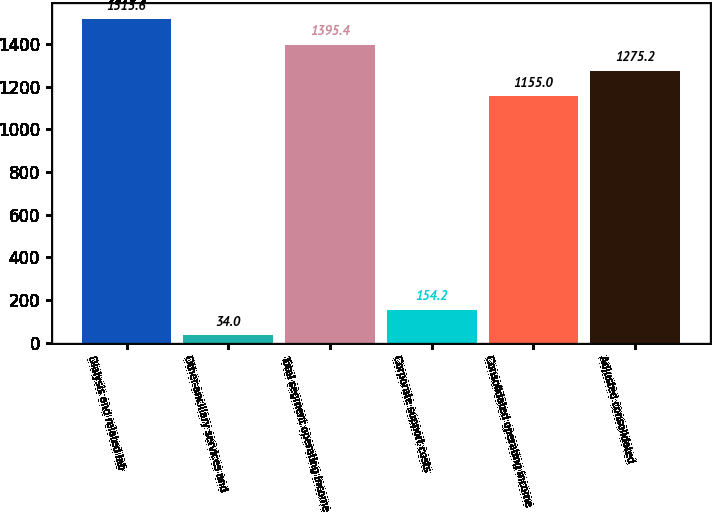<chart> <loc_0><loc_0><loc_500><loc_500><bar_chart><fcel>Dialysis and related lab<fcel>Other-ancillary services and<fcel>Total segment operating income<fcel>Corporate support costs<fcel>Consolidated operating income<fcel>Adjusted consolidated<nl><fcel>1515.6<fcel>34<fcel>1395.4<fcel>154.2<fcel>1155<fcel>1275.2<nl></chart> 